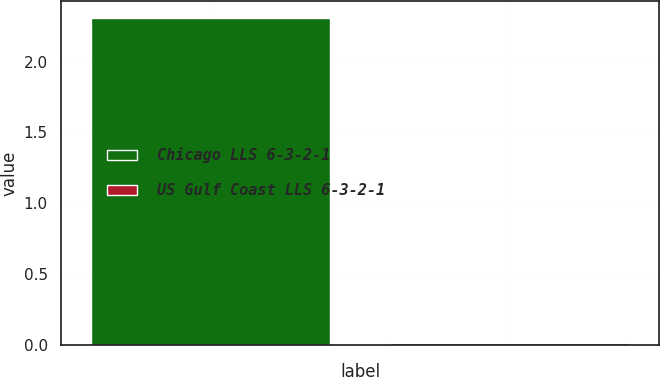<chart> <loc_0><loc_0><loc_500><loc_500><bar_chart><fcel>Chicago LLS 6-3-2-1<fcel>US Gulf Coast LLS 6-3-2-1<nl><fcel>2.31<fcel>0.01<nl></chart> 